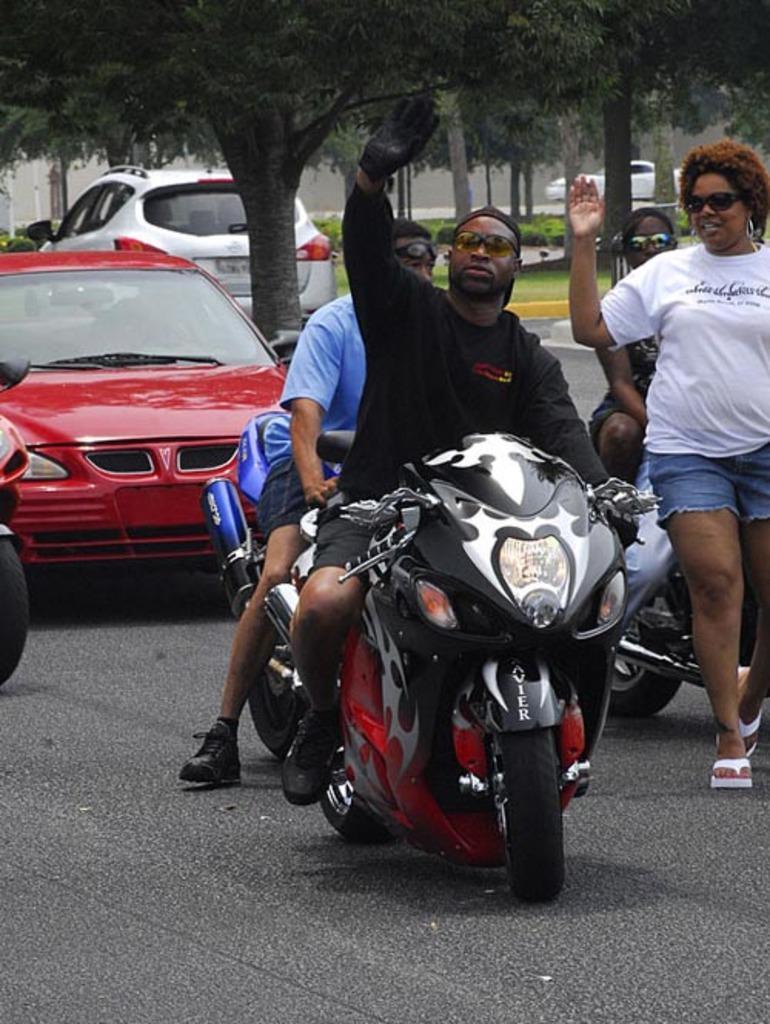Please provide a concise description of this image. In this image I can see the vehicles on the road. Some people are riding the motorbike. At the background there are trees. 